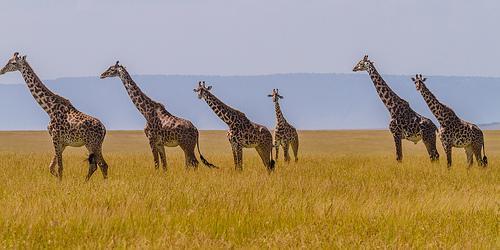How many humans are in the picture?
Give a very brief answer. 0. How many elephants are pictured?
Give a very brief answer. 0. 